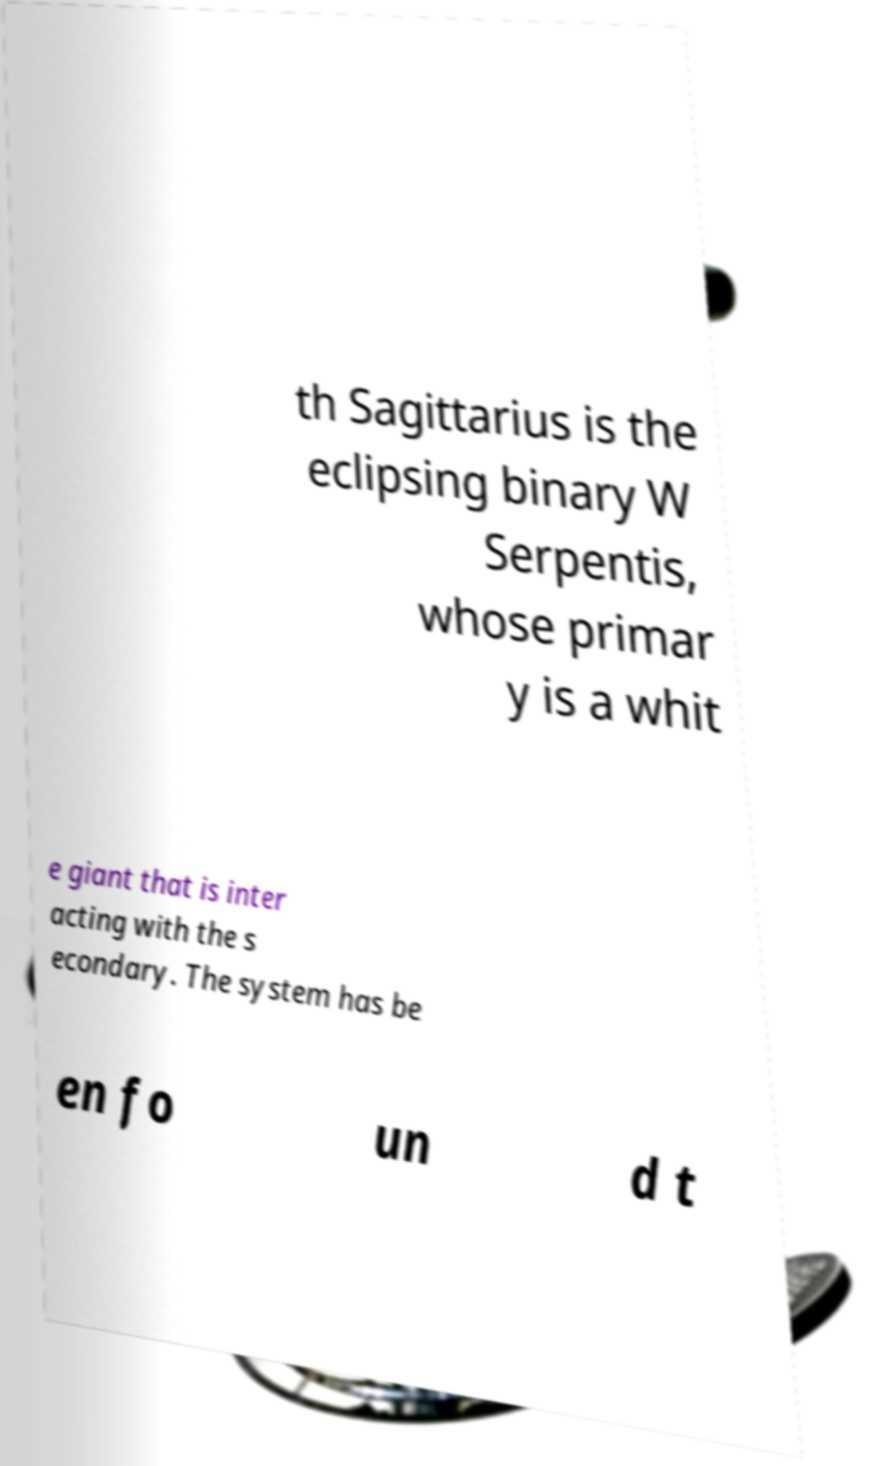Can you accurately transcribe the text from the provided image for me? th Sagittarius is the eclipsing binary W Serpentis, whose primar y is a whit e giant that is inter acting with the s econdary. The system has be en fo un d t 